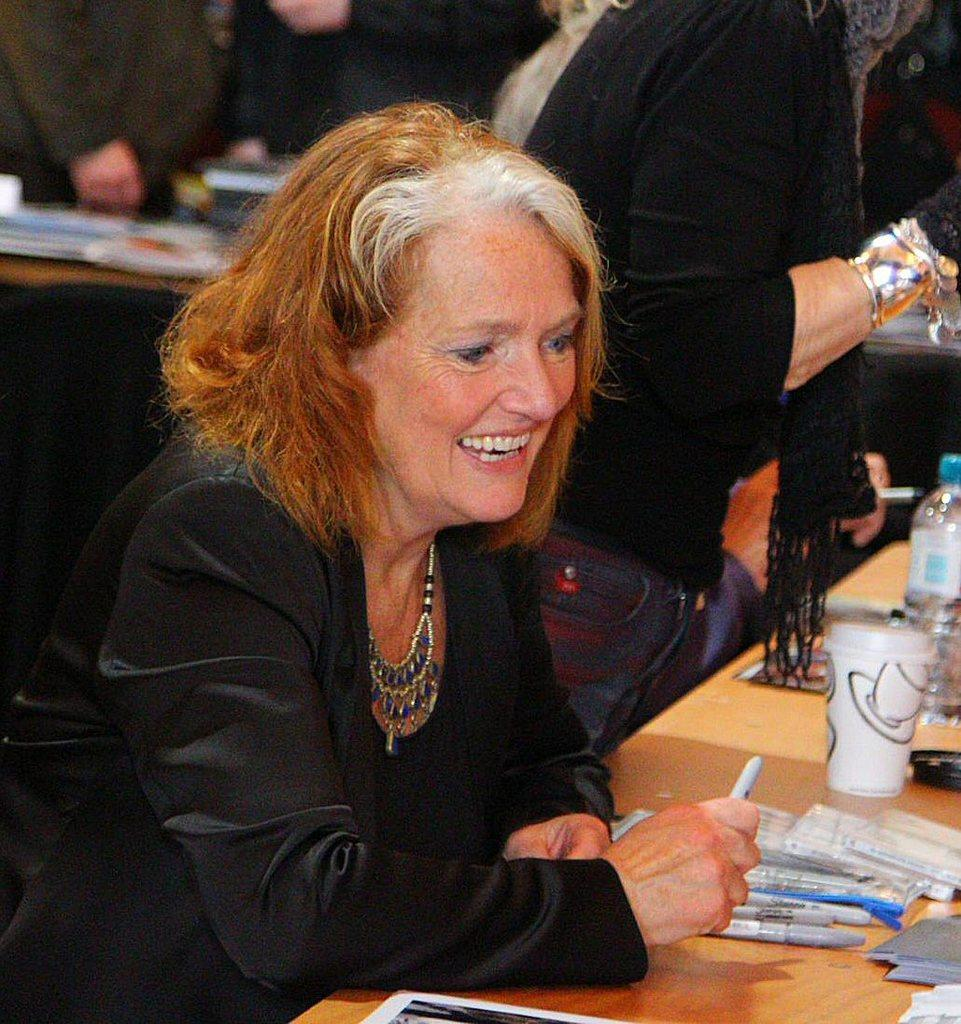Who is present in the image? There is a lady in the image. What is the lady's facial expression? The lady has a smiling face. What type of container is visible in the image? There is a glass in the image. What writing instruments are present in the image? There are pens in the image. What other type of container is visible in the image? There is a bottle in the image. What material is the surface on which the objects are placed? The objects are on a wooden surface. What type of representative is present in the image? There is no representative present in the image; it features a lady with a smiling face, a glass, pens, a bottle, and objects on a wooden surface. Can you hear the lady's aunt playing a horn in the image? There is no horn or any indication of the lady's aunt in the image. 